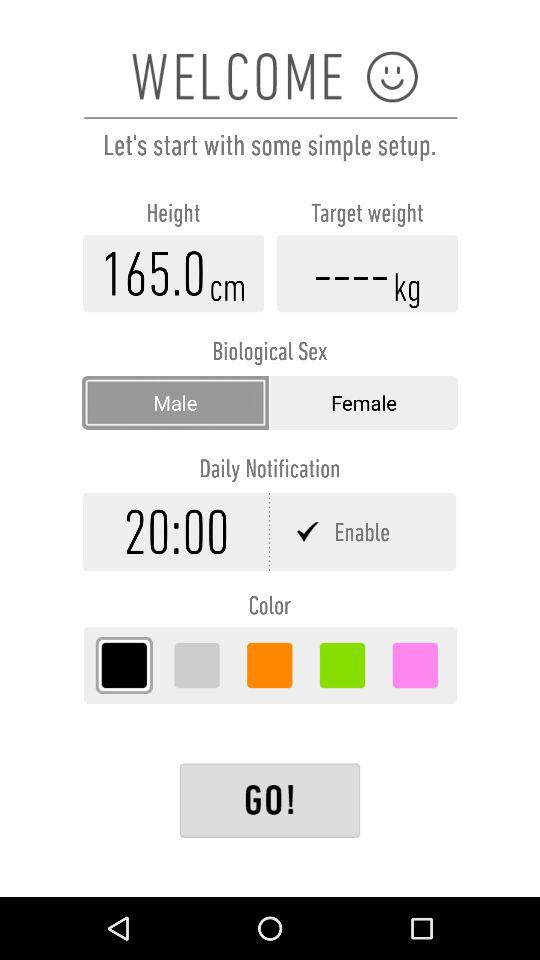What is the status of "Daily Notification"? The status is "Enable". 